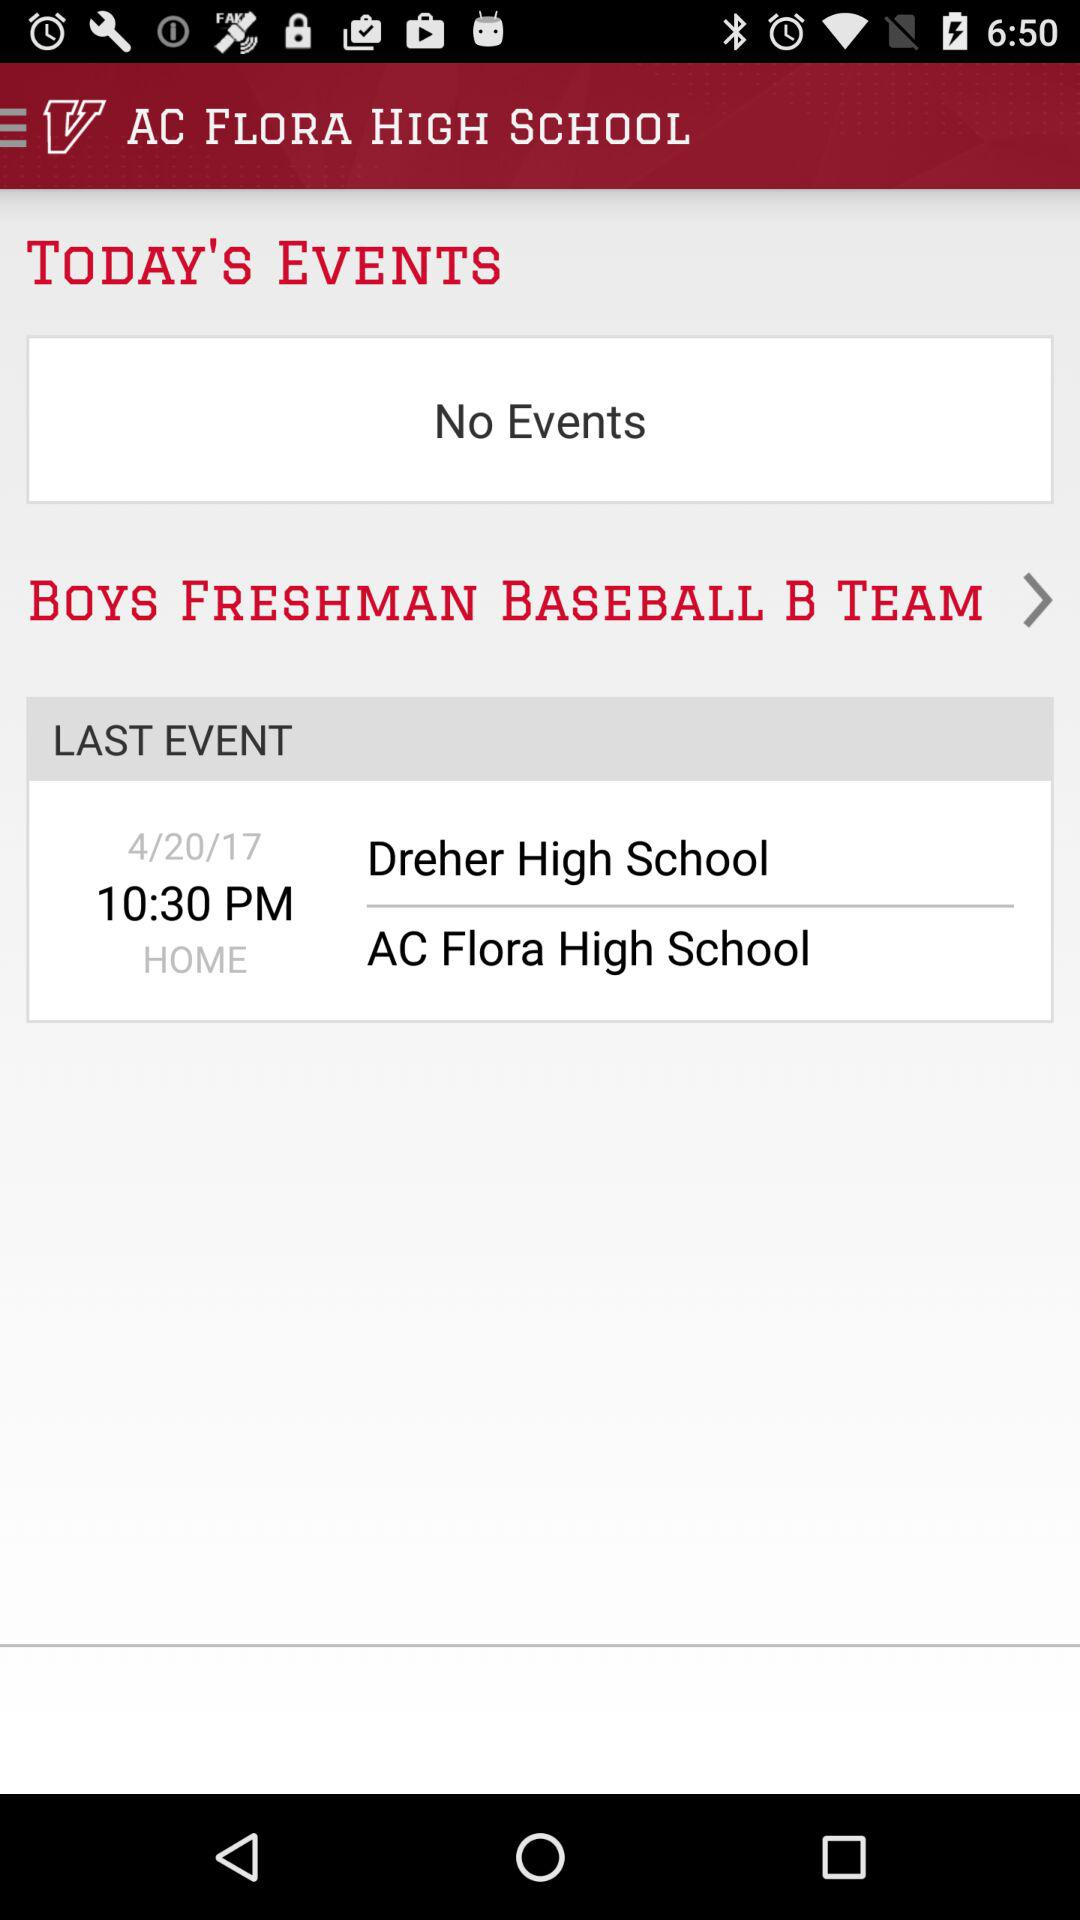Is there any event today? There is no event. 